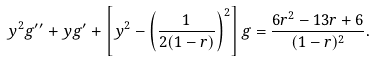<formula> <loc_0><loc_0><loc_500><loc_500>y ^ { 2 } g ^ { \prime \prime } + y g ^ { \prime } + \left [ y ^ { 2 } - \left ( \frac { 1 } { 2 ( 1 - r ) } \right ) ^ { 2 } \right ] g = \frac { 6 r ^ { 2 } - 1 3 r + 6 } { ( 1 - r ) ^ { 2 } } .</formula> 